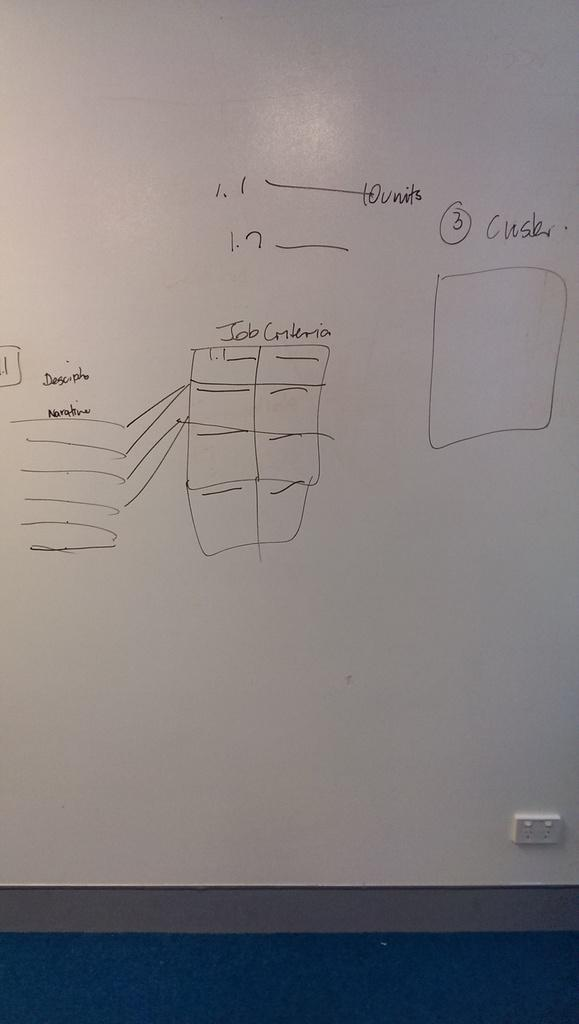<image>
Offer a succinct explanation of the picture presented. The whiteboard has a diagram depicting job criteria drawn on it. 